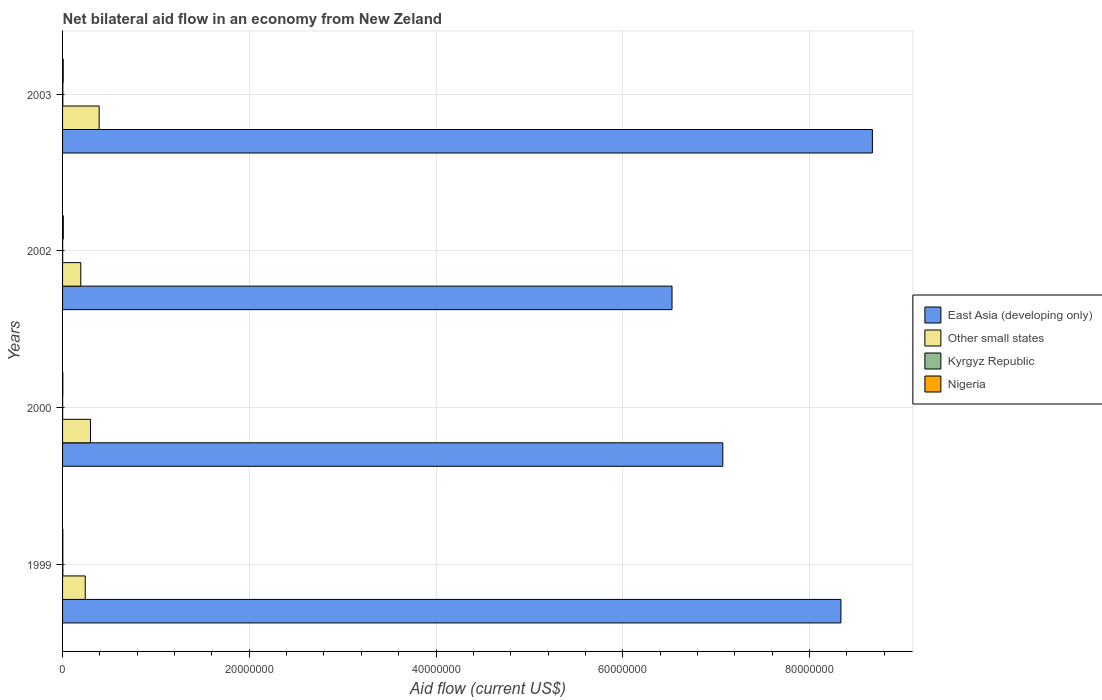Are the number of bars per tick equal to the number of legend labels?
Provide a succinct answer. Yes. Are the number of bars on each tick of the Y-axis equal?
Offer a very short reply. Yes. What is the net bilateral aid flow in Kyrgyz Republic in 2000?
Your response must be concise. 10000. Across all years, what is the maximum net bilateral aid flow in Kyrgyz Republic?
Offer a very short reply. 3.00e+04. Across all years, what is the minimum net bilateral aid flow in East Asia (developing only)?
Keep it short and to the point. 6.53e+07. What is the difference between the net bilateral aid flow in Other small states in 2002 and that in 2003?
Provide a short and direct response. -1.97e+06. What is the difference between the net bilateral aid flow in East Asia (developing only) in 1999 and the net bilateral aid flow in Nigeria in 2003?
Your answer should be compact. 8.33e+07. What is the average net bilateral aid flow in Kyrgyz Republic per year?
Ensure brevity in your answer.  2.00e+04. In the year 1999, what is the difference between the net bilateral aid flow in Other small states and net bilateral aid flow in Nigeria?
Your answer should be very brief. 2.40e+06. In how many years, is the net bilateral aid flow in East Asia (developing only) greater than 8000000 US$?
Your response must be concise. 4. What is the ratio of the net bilateral aid flow in East Asia (developing only) in 2000 to that in 2003?
Your response must be concise. 0.82. Is the net bilateral aid flow in Other small states in 2002 less than that in 2003?
Your response must be concise. Yes. What is the difference between the highest and the lowest net bilateral aid flow in Kyrgyz Republic?
Offer a very short reply. 2.00e+04. In how many years, is the net bilateral aid flow in Nigeria greater than the average net bilateral aid flow in Nigeria taken over all years?
Your answer should be very brief. 2. Is the sum of the net bilateral aid flow in East Asia (developing only) in 2002 and 2003 greater than the maximum net bilateral aid flow in Nigeria across all years?
Ensure brevity in your answer.  Yes. What does the 1st bar from the top in 2002 represents?
Ensure brevity in your answer.  Nigeria. What does the 3rd bar from the bottom in 1999 represents?
Provide a succinct answer. Kyrgyz Republic. Where does the legend appear in the graph?
Offer a terse response. Center right. How many legend labels are there?
Your answer should be compact. 4. How are the legend labels stacked?
Offer a terse response. Vertical. What is the title of the graph?
Offer a very short reply. Net bilateral aid flow in an economy from New Zeland. Does "Bhutan" appear as one of the legend labels in the graph?
Provide a succinct answer. No. What is the label or title of the Y-axis?
Ensure brevity in your answer.  Years. What is the Aid flow (current US$) in East Asia (developing only) in 1999?
Your answer should be compact. 8.34e+07. What is the Aid flow (current US$) in Other small states in 1999?
Make the answer very short. 2.43e+06. What is the Aid flow (current US$) of Kyrgyz Republic in 1999?
Offer a very short reply. 3.00e+04. What is the Aid flow (current US$) in Nigeria in 1999?
Your answer should be compact. 3.00e+04. What is the Aid flow (current US$) of East Asia (developing only) in 2000?
Your answer should be compact. 7.07e+07. What is the Aid flow (current US$) of Other small states in 2000?
Provide a short and direct response. 2.99e+06. What is the Aid flow (current US$) in East Asia (developing only) in 2002?
Offer a very short reply. 6.53e+07. What is the Aid flow (current US$) in Other small states in 2002?
Your response must be concise. 1.95e+06. What is the Aid flow (current US$) of Nigeria in 2002?
Keep it short and to the point. 8.00e+04. What is the Aid flow (current US$) of East Asia (developing only) in 2003?
Your answer should be compact. 8.67e+07. What is the Aid flow (current US$) in Other small states in 2003?
Provide a succinct answer. 3.92e+06. What is the Aid flow (current US$) in Kyrgyz Republic in 2003?
Provide a short and direct response. 3.00e+04. Across all years, what is the maximum Aid flow (current US$) in East Asia (developing only)?
Make the answer very short. 8.67e+07. Across all years, what is the maximum Aid flow (current US$) in Other small states?
Your response must be concise. 3.92e+06. Across all years, what is the maximum Aid flow (current US$) in Kyrgyz Republic?
Your answer should be very brief. 3.00e+04. Across all years, what is the maximum Aid flow (current US$) in Nigeria?
Offer a terse response. 8.00e+04. Across all years, what is the minimum Aid flow (current US$) of East Asia (developing only)?
Keep it short and to the point. 6.53e+07. Across all years, what is the minimum Aid flow (current US$) of Other small states?
Your response must be concise. 1.95e+06. Across all years, what is the minimum Aid flow (current US$) in Nigeria?
Offer a terse response. 3.00e+04. What is the total Aid flow (current US$) of East Asia (developing only) in the graph?
Your response must be concise. 3.06e+08. What is the total Aid flow (current US$) of Other small states in the graph?
Your answer should be very brief. 1.13e+07. What is the total Aid flow (current US$) in Kyrgyz Republic in the graph?
Keep it short and to the point. 8.00e+04. What is the total Aid flow (current US$) of Nigeria in the graph?
Provide a succinct answer. 2.10e+05. What is the difference between the Aid flow (current US$) of East Asia (developing only) in 1999 and that in 2000?
Give a very brief answer. 1.26e+07. What is the difference between the Aid flow (current US$) of Other small states in 1999 and that in 2000?
Your response must be concise. -5.60e+05. What is the difference between the Aid flow (current US$) of East Asia (developing only) in 1999 and that in 2002?
Provide a succinct answer. 1.81e+07. What is the difference between the Aid flow (current US$) in Nigeria in 1999 and that in 2002?
Offer a terse response. -5.00e+04. What is the difference between the Aid flow (current US$) of East Asia (developing only) in 1999 and that in 2003?
Keep it short and to the point. -3.37e+06. What is the difference between the Aid flow (current US$) of Other small states in 1999 and that in 2003?
Offer a very short reply. -1.49e+06. What is the difference between the Aid flow (current US$) in Nigeria in 1999 and that in 2003?
Offer a very short reply. -4.00e+04. What is the difference between the Aid flow (current US$) of East Asia (developing only) in 2000 and that in 2002?
Provide a succinct answer. 5.44e+06. What is the difference between the Aid flow (current US$) in Other small states in 2000 and that in 2002?
Keep it short and to the point. 1.04e+06. What is the difference between the Aid flow (current US$) of Kyrgyz Republic in 2000 and that in 2002?
Provide a succinct answer. 0. What is the difference between the Aid flow (current US$) in East Asia (developing only) in 2000 and that in 2003?
Your answer should be very brief. -1.60e+07. What is the difference between the Aid flow (current US$) of Other small states in 2000 and that in 2003?
Offer a terse response. -9.30e+05. What is the difference between the Aid flow (current US$) in Kyrgyz Republic in 2000 and that in 2003?
Your answer should be compact. -2.00e+04. What is the difference between the Aid flow (current US$) of East Asia (developing only) in 2002 and that in 2003?
Offer a terse response. -2.15e+07. What is the difference between the Aid flow (current US$) of Other small states in 2002 and that in 2003?
Your answer should be very brief. -1.97e+06. What is the difference between the Aid flow (current US$) in Nigeria in 2002 and that in 2003?
Keep it short and to the point. 10000. What is the difference between the Aid flow (current US$) of East Asia (developing only) in 1999 and the Aid flow (current US$) of Other small states in 2000?
Offer a terse response. 8.04e+07. What is the difference between the Aid flow (current US$) in East Asia (developing only) in 1999 and the Aid flow (current US$) in Kyrgyz Republic in 2000?
Make the answer very short. 8.34e+07. What is the difference between the Aid flow (current US$) in East Asia (developing only) in 1999 and the Aid flow (current US$) in Nigeria in 2000?
Provide a short and direct response. 8.33e+07. What is the difference between the Aid flow (current US$) in Other small states in 1999 and the Aid flow (current US$) in Kyrgyz Republic in 2000?
Provide a succinct answer. 2.42e+06. What is the difference between the Aid flow (current US$) of Other small states in 1999 and the Aid flow (current US$) of Nigeria in 2000?
Provide a short and direct response. 2.40e+06. What is the difference between the Aid flow (current US$) of Kyrgyz Republic in 1999 and the Aid flow (current US$) of Nigeria in 2000?
Keep it short and to the point. 0. What is the difference between the Aid flow (current US$) in East Asia (developing only) in 1999 and the Aid flow (current US$) in Other small states in 2002?
Give a very brief answer. 8.14e+07. What is the difference between the Aid flow (current US$) in East Asia (developing only) in 1999 and the Aid flow (current US$) in Kyrgyz Republic in 2002?
Your response must be concise. 8.34e+07. What is the difference between the Aid flow (current US$) in East Asia (developing only) in 1999 and the Aid flow (current US$) in Nigeria in 2002?
Your answer should be compact. 8.33e+07. What is the difference between the Aid flow (current US$) of Other small states in 1999 and the Aid flow (current US$) of Kyrgyz Republic in 2002?
Give a very brief answer. 2.42e+06. What is the difference between the Aid flow (current US$) of Other small states in 1999 and the Aid flow (current US$) of Nigeria in 2002?
Provide a short and direct response. 2.35e+06. What is the difference between the Aid flow (current US$) in Kyrgyz Republic in 1999 and the Aid flow (current US$) in Nigeria in 2002?
Your answer should be compact. -5.00e+04. What is the difference between the Aid flow (current US$) of East Asia (developing only) in 1999 and the Aid flow (current US$) of Other small states in 2003?
Provide a succinct answer. 7.94e+07. What is the difference between the Aid flow (current US$) of East Asia (developing only) in 1999 and the Aid flow (current US$) of Kyrgyz Republic in 2003?
Keep it short and to the point. 8.33e+07. What is the difference between the Aid flow (current US$) in East Asia (developing only) in 1999 and the Aid flow (current US$) in Nigeria in 2003?
Keep it short and to the point. 8.33e+07. What is the difference between the Aid flow (current US$) of Other small states in 1999 and the Aid flow (current US$) of Kyrgyz Republic in 2003?
Keep it short and to the point. 2.40e+06. What is the difference between the Aid flow (current US$) in Other small states in 1999 and the Aid flow (current US$) in Nigeria in 2003?
Your response must be concise. 2.36e+06. What is the difference between the Aid flow (current US$) in East Asia (developing only) in 2000 and the Aid flow (current US$) in Other small states in 2002?
Ensure brevity in your answer.  6.88e+07. What is the difference between the Aid flow (current US$) of East Asia (developing only) in 2000 and the Aid flow (current US$) of Kyrgyz Republic in 2002?
Your answer should be very brief. 7.07e+07. What is the difference between the Aid flow (current US$) of East Asia (developing only) in 2000 and the Aid flow (current US$) of Nigeria in 2002?
Your response must be concise. 7.06e+07. What is the difference between the Aid flow (current US$) of Other small states in 2000 and the Aid flow (current US$) of Kyrgyz Republic in 2002?
Give a very brief answer. 2.98e+06. What is the difference between the Aid flow (current US$) in Other small states in 2000 and the Aid flow (current US$) in Nigeria in 2002?
Your answer should be very brief. 2.91e+06. What is the difference between the Aid flow (current US$) of East Asia (developing only) in 2000 and the Aid flow (current US$) of Other small states in 2003?
Provide a short and direct response. 6.68e+07. What is the difference between the Aid flow (current US$) of East Asia (developing only) in 2000 and the Aid flow (current US$) of Kyrgyz Republic in 2003?
Your answer should be compact. 7.07e+07. What is the difference between the Aid flow (current US$) of East Asia (developing only) in 2000 and the Aid flow (current US$) of Nigeria in 2003?
Ensure brevity in your answer.  7.06e+07. What is the difference between the Aid flow (current US$) in Other small states in 2000 and the Aid flow (current US$) in Kyrgyz Republic in 2003?
Offer a very short reply. 2.96e+06. What is the difference between the Aid flow (current US$) of Other small states in 2000 and the Aid flow (current US$) of Nigeria in 2003?
Offer a very short reply. 2.92e+06. What is the difference between the Aid flow (current US$) of Kyrgyz Republic in 2000 and the Aid flow (current US$) of Nigeria in 2003?
Provide a succinct answer. -6.00e+04. What is the difference between the Aid flow (current US$) in East Asia (developing only) in 2002 and the Aid flow (current US$) in Other small states in 2003?
Provide a short and direct response. 6.14e+07. What is the difference between the Aid flow (current US$) in East Asia (developing only) in 2002 and the Aid flow (current US$) in Kyrgyz Republic in 2003?
Your answer should be very brief. 6.52e+07. What is the difference between the Aid flow (current US$) in East Asia (developing only) in 2002 and the Aid flow (current US$) in Nigeria in 2003?
Provide a short and direct response. 6.52e+07. What is the difference between the Aid flow (current US$) in Other small states in 2002 and the Aid flow (current US$) in Kyrgyz Republic in 2003?
Make the answer very short. 1.92e+06. What is the difference between the Aid flow (current US$) of Other small states in 2002 and the Aid flow (current US$) of Nigeria in 2003?
Make the answer very short. 1.88e+06. What is the average Aid flow (current US$) in East Asia (developing only) per year?
Give a very brief answer. 7.65e+07. What is the average Aid flow (current US$) of Other small states per year?
Your answer should be very brief. 2.82e+06. What is the average Aid flow (current US$) in Nigeria per year?
Keep it short and to the point. 5.25e+04. In the year 1999, what is the difference between the Aid flow (current US$) of East Asia (developing only) and Aid flow (current US$) of Other small states?
Provide a short and direct response. 8.09e+07. In the year 1999, what is the difference between the Aid flow (current US$) in East Asia (developing only) and Aid flow (current US$) in Kyrgyz Republic?
Your response must be concise. 8.33e+07. In the year 1999, what is the difference between the Aid flow (current US$) of East Asia (developing only) and Aid flow (current US$) of Nigeria?
Provide a short and direct response. 8.33e+07. In the year 1999, what is the difference between the Aid flow (current US$) in Other small states and Aid flow (current US$) in Kyrgyz Republic?
Make the answer very short. 2.40e+06. In the year 1999, what is the difference between the Aid flow (current US$) in Other small states and Aid flow (current US$) in Nigeria?
Your answer should be compact. 2.40e+06. In the year 2000, what is the difference between the Aid flow (current US$) of East Asia (developing only) and Aid flow (current US$) of Other small states?
Your answer should be very brief. 6.77e+07. In the year 2000, what is the difference between the Aid flow (current US$) in East Asia (developing only) and Aid flow (current US$) in Kyrgyz Republic?
Keep it short and to the point. 7.07e+07. In the year 2000, what is the difference between the Aid flow (current US$) in East Asia (developing only) and Aid flow (current US$) in Nigeria?
Make the answer very short. 7.07e+07. In the year 2000, what is the difference between the Aid flow (current US$) of Other small states and Aid flow (current US$) of Kyrgyz Republic?
Your answer should be very brief. 2.98e+06. In the year 2000, what is the difference between the Aid flow (current US$) in Other small states and Aid flow (current US$) in Nigeria?
Give a very brief answer. 2.96e+06. In the year 2002, what is the difference between the Aid flow (current US$) in East Asia (developing only) and Aid flow (current US$) in Other small states?
Ensure brevity in your answer.  6.33e+07. In the year 2002, what is the difference between the Aid flow (current US$) of East Asia (developing only) and Aid flow (current US$) of Kyrgyz Republic?
Your answer should be very brief. 6.53e+07. In the year 2002, what is the difference between the Aid flow (current US$) of East Asia (developing only) and Aid flow (current US$) of Nigeria?
Your answer should be compact. 6.52e+07. In the year 2002, what is the difference between the Aid flow (current US$) of Other small states and Aid flow (current US$) of Kyrgyz Republic?
Provide a short and direct response. 1.94e+06. In the year 2002, what is the difference between the Aid flow (current US$) in Other small states and Aid flow (current US$) in Nigeria?
Offer a terse response. 1.87e+06. In the year 2003, what is the difference between the Aid flow (current US$) in East Asia (developing only) and Aid flow (current US$) in Other small states?
Provide a succinct answer. 8.28e+07. In the year 2003, what is the difference between the Aid flow (current US$) in East Asia (developing only) and Aid flow (current US$) in Kyrgyz Republic?
Provide a succinct answer. 8.67e+07. In the year 2003, what is the difference between the Aid flow (current US$) of East Asia (developing only) and Aid flow (current US$) of Nigeria?
Your response must be concise. 8.67e+07. In the year 2003, what is the difference between the Aid flow (current US$) of Other small states and Aid flow (current US$) of Kyrgyz Republic?
Provide a succinct answer. 3.89e+06. In the year 2003, what is the difference between the Aid flow (current US$) of Other small states and Aid flow (current US$) of Nigeria?
Provide a short and direct response. 3.85e+06. What is the ratio of the Aid flow (current US$) in East Asia (developing only) in 1999 to that in 2000?
Your answer should be compact. 1.18. What is the ratio of the Aid flow (current US$) of Other small states in 1999 to that in 2000?
Make the answer very short. 0.81. What is the ratio of the Aid flow (current US$) in East Asia (developing only) in 1999 to that in 2002?
Your answer should be compact. 1.28. What is the ratio of the Aid flow (current US$) in Other small states in 1999 to that in 2002?
Offer a terse response. 1.25. What is the ratio of the Aid flow (current US$) of Kyrgyz Republic in 1999 to that in 2002?
Keep it short and to the point. 3. What is the ratio of the Aid flow (current US$) of Nigeria in 1999 to that in 2002?
Give a very brief answer. 0.38. What is the ratio of the Aid flow (current US$) of East Asia (developing only) in 1999 to that in 2003?
Offer a very short reply. 0.96. What is the ratio of the Aid flow (current US$) in Other small states in 1999 to that in 2003?
Provide a short and direct response. 0.62. What is the ratio of the Aid flow (current US$) of Kyrgyz Republic in 1999 to that in 2003?
Make the answer very short. 1. What is the ratio of the Aid flow (current US$) of Nigeria in 1999 to that in 2003?
Your answer should be very brief. 0.43. What is the ratio of the Aid flow (current US$) of East Asia (developing only) in 2000 to that in 2002?
Keep it short and to the point. 1.08. What is the ratio of the Aid flow (current US$) in Other small states in 2000 to that in 2002?
Your answer should be compact. 1.53. What is the ratio of the Aid flow (current US$) of Kyrgyz Republic in 2000 to that in 2002?
Ensure brevity in your answer.  1. What is the ratio of the Aid flow (current US$) of Nigeria in 2000 to that in 2002?
Ensure brevity in your answer.  0.38. What is the ratio of the Aid flow (current US$) in East Asia (developing only) in 2000 to that in 2003?
Offer a very short reply. 0.82. What is the ratio of the Aid flow (current US$) in Other small states in 2000 to that in 2003?
Provide a succinct answer. 0.76. What is the ratio of the Aid flow (current US$) in Kyrgyz Republic in 2000 to that in 2003?
Your answer should be compact. 0.33. What is the ratio of the Aid flow (current US$) of Nigeria in 2000 to that in 2003?
Provide a succinct answer. 0.43. What is the ratio of the Aid flow (current US$) in East Asia (developing only) in 2002 to that in 2003?
Offer a terse response. 0.75. What is the ratio of the Aid flow (current US$) of Other small states in 2002 to that in 2003?
Your response must be concise. 0.5. What is the difference between the highest and the second highest Aid flow (current US$) in East Asia (developing only)?
Give a very brief answer. 3.37e+06. What is the difference between the highest and the second highest Aid flow (current US$) of Other small states?
Offer a terse response. 9.30e+05. What is the difference between the highest and the second highest Aid flow (current US$) of Nigeria?
Your answer should be very brief. 10000. What is the difference between the highest and the lowest Aid flow (current US$) of East Asia (developing only)?
Your answer should be compact. 2.15e+07. What is the difference between the highest and the lowest Aid flow (current US$) in Other small states?
Offer a very short reply. 1.97e+06. What is the difference between the highest and the lowest Aid flow (current US$) in Kyrgyz Republic?
Keep it short and to the point. 2.00e+04. 